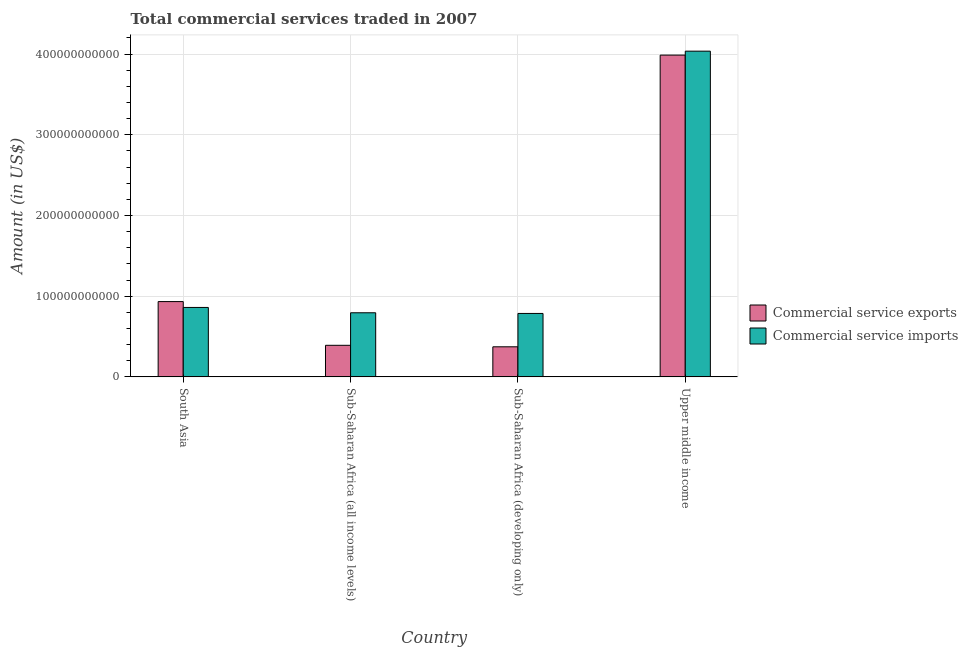How many different coloured bars are there?
Your answer should be very brief. 2. How many groups of bars are there?
Your answer should be very brief. 4. Are the number of bars per tick equal to the number of legend labels?
Keep it short and to the point. Yes. Are the number of bars on each tick of the X-axis equal?
Keep it short and to the point. Yes. What is the label of the 2nd group of bars from the left?
Make the answer very short. Sub-Saharan Africa (all income levels). What is the amount of commercial service imports in Upper middle income?
Provide a succinct answer. 4.04e+11. Across all countries, what is the maximum amount of commercial service imports?
Provide a short and direct response. 4.04e+11. Across all countries, what is the minimum amount of commercial service exports?
Provide a succinct answer. 3.73e+1. In which country was the amount of commercial service imports maximum?
Keep it short and to the point. Upper middle income. In which country was the amount of commercial service imports minimum?
Make the answer very short. Sub-Saharan Africa (developing only). What is the total amount of commercial service imports in the graph?
Ensure brevity in your answer.  6.48e+11. What is the difference between the amount of commercial service imports in Sub-Saharan Africa (all income levels) and that in Sub-Saharan Africa (developing only)?
Your answer should be very brief. 8.37e+08. What is the difference between the amount of commercial service imports in Sub-Saharan Africa (all income levels) and the amount of commercial service exports in Upper middle income?
Provide a succinct answer. -3.19e+11. What is the average amount of commercial service imports per country?
Keep it short and to the point. 1.62e+11. What is the difference between the amount of commercial service imports and amount of commercial service exports in Sub-Saharan Africa (all income levels)?
Your answer should be very brief. 4.03e+1. What is the ratio of the amount of commercial service imports in Sub-Saharan Africa (all income levels) to that in Upper middle income?
Offer a very short reply. 0.2. Is the amount of commercial service exports in Sub-Saharan Africa (developing only) less than that in Upper middle income?
Provide a short and direct response. Yes. What is the difference between the highest and the second highest amount of commercial service imports?
Offer a terse response. 3.18e+11. What is the difference between the highest and the lowest amount of commercial service imports?
Provide a succinct answer. 3.25e+11. What does the 1st bar from the left in South Asia represents?
Ensure brevity in your answer.  Commercial service exports. What does the 2nd bar from the right in Sub-Saharan Africa (all income levels) represents?
Your answer should be very brief. Commercial service exports. How many bars are there?
Keep it short and to the point. 8. Are all the bars in the graph horizontal?
Ensure brevity in your answer.  No. What is the difference between two consecutive major ticks on the Y-axis?
Offer a very short reply. 1.00e+11. Does the graph contain any zero values?
Ensure brevity in your answer.  No. Where does the legend appear in the graph?
Your answer should be compact. Center right. How many legend labels are there?
Give a very brief answer. 2. What is the title of the graph?
Keep it short and to the point. Total commercial services traded in 2007. What is the Amount (in US$) in Commercial service exports in South Asia?
Provide a short and direct response. 9.33e+1. What is the Amount (in US$) in Commercial service imports in South Asia?
Your answer should be very brief. 8.60e+1. What is the Amount (in US$) in Commercial service exports in Sub-Saharan Africa (all income levels)?
Keep it short and to the point. 3.91e+1. What is the Amount (in US$) of Commercial service imports in Sub-Saharan Africa (all income levels)?
Provide a short and direct response. 7.94e+1. What is the Amount (in US$) of Commercial service exports in Sub-Saharan Africa (developing only)?
Ensure brevity in your answer.  3.73e+1. What is the Amount (in US$) of Commercial service imports in Sub-Saharan Africa (developing only)?
Provide a succinct answer. 7.86e+1. What is the Amount (in US$) of Commercial service exports in Upper middle income?
Offer a very short reply. 3.99e+11. What is the Amount (in US$) of Commercial service imports in Upper middle income?
Make the answer very short. 4.04e+11. Across all countries, what is the maximum Amount (in US$) in Commercial service exports?
Offer a very short reply. 3.99e+11. Across all countries, what is the maximum Amount (in US$) in Commercial service imports?
Your answer should be very brief. 4.04e+11. Across all countries, what is the minimum Amount (in US$) of Commercial service exports?
Give a very brief answer. 3.73e+1. Across all countries, what is the minimum Amount (in US$) of Commercial service imports?
Provide a succinct answer. 7.86e+1. What is the total Amount (in US$) in Commercial service exports in the graph?
Give a very brief answer. 5.68e+11. What is the total Amount (in US$) of Commercial service imports in the graph?
Keep it short and to the point. 6.48e+11. What is the difference between the Amount (in US$) of Commercial service exports in South Asia and that in Sub-Saharan Africa (all income levels)?
Make the answer very short. 5.42e+1. What is the difference between the Amount (in US$) of Commercial service imports in South Asia and that in Sub-Saharan Africa (all income levels)?
Offer a very short reply. 6.59e+09. What is the difference between the Amount (in US$) of Commercial service exports in South Asia and that in Sub-Saharan Africa (developing only)?
Provide a succinct answer. 5.60e+1. What is the difference between the Amount (in US$) of Commercial service imports in South Asia and that in Sub-Saharan Africa (developing only)?
Your answer should be very brief. 7.43e+09. What is the difference between the Amount (in US$) in Commercial service exports in South Asia and that in Upper middle income?
Offer a very short reply. -3.05e+11. What is the difference between the Amount (in US$) of Commercial service imports in South Asia and that in Upper middle income?
Offer a very short reply. -3.18e+11. What is the difference between the Amount (in US$) of Commercial service exports in Sub-Saharan Africa (all income levels) and that in Sub-Saharan Africa (developing only)?
Your answer should be very brief. 1.86e+09. What is the difference between the Amount (in US$) of Commercial service imports in Sub-Saharan Africa (all income levels) and that in Sub-Saharan Africa (developing only)?
Offer a very short reply. 8.37e+08. What is the difference between the Amount (in US$) of Commercial service exports in Sub-Saharan Africa (all income levels) and that in Upper middle income?
Offer a terse response. -3.60e+11. What is the difference between the Amount (in US$) in Commercial service imports in Sub-Saharan Africa (all income levels) and that in Upper middle income?
Your response must be concise. -3.24e+11. What is the difference between the Amount (in US$) in Commercial service exports in Sub-Saharan Africa (developing only) and that in Upper middle income?
Your response must be concise. -3.61e+11. What is the difference between the Amount (in US$) of Commercial service imports in Sub-Saharan Africa (developing only) and that in Upper middle income?
Provide a succinct answer. -3.25e+11. What is the difference between the Amount (in US$) in Commercial service exports in South Asia and the Amount (in US$) in Commercial service imports in Sub-Saharan Africa (all income levels)?
Your answer should be compact. 1.39e+1. What is the difference between the Amount (in US$) in Commercial service exports in South Asia and the Amount (in US$) in Commercial service imports in Sub-Saharan Africa (developing only)?
Provide a short and direct response. 1.47e+1. What is the difference between the Amount (in US$) in Commercial service exports in South Asia and the Amount (in US$) in Commercial service imports in Upper middle income?
Give a very brief answer. -3.10e+11. What is the difference between the Amount (in US$) in Commercial service exports in Sub-Saharan Africa (all income levels) and the Amount (in US$) in Commercial service imports in Sub-Saharan Africa (developing only)?
Provide a succinct answer. -3.95e+1. What is the difference between the Amount (in US$) of Commercial service exports in Sub-Saharan Africa (all income levels) and the Amount (in US$) of Commercial service imports in Upper middle income?
Give a very brief answer. -3.64e+11. What is the difference between the Amount (in US$) in Commercial service exports in Sub-Saharan Africa (developing only) and the Amount (in US$) in Commercial service imports in Upper middle income?
Offer a terse response. -3.66e+11. What is the average Amount (in US$) in Commercial service exports per country?
Provide a short and direct response. 1.42e+11. What is the average Amount (in US$) in Commercial service imports per country?
Offer a very short reply. 1.62e+11. What is the difference between the Amount (in US$) of Commercial service exports and Amount (in US$) of Commercial service imports in South Asia?
Your answer should be compact. 7.27e+09. What is the difference between the Amount (in US$) in Commercial service exports and Amount (in US$) in Commercial service imports in Sub-Saharan Africa (all income levels)?
Provide a short and direct response. -4.03e+1. What is the difference between the Amount (in US$) in Commercial service exports and Amount (in US$) in Commercial service imports in Sub-Saharan Africa (developing only)?
Offer a terse response. -4.13e+1. What is the difference between the Amount (in US$) of Commercial service exports and Amount (in US$) of Commercial service imports in Upper middle income?
Your answer should be very brief. -4.89e+09. What is the ratio of the Amount (in US$) of Commercial service exports in South Asia to that in Sub-Saharan Africa (all income levels)?
Offer a very short reply. 2.38. What is the ratio of the Amount (in US$) in Commercial service imports in South Asia to that in Sub-Saharan Africa (all income levels)?
Offer a terse response. 1.08. What is the ratio of the Amount (in US$) in Commercial service exports in South Asia to that in Sub-Saharan Africa (developing only)?
Offer a very short reply. 2.5. What is the ratio of the Amount (in US$) of Commercial service imports in South Asia to that in Sub-Saharan Africa (developing only)?
Ensure brevity in your answer.  1.09. What is the ratio of the Amount (in US$) in Commercial service exports in South Asia to that in Upper middle income?
Offer a terse response. 0.23. What is the ratio of the Amount (in US$) in Commercial service imports in South Asia to that in Upper middle income?
Ensure brevity in your answer.  0.21. What is the ratio of the Amount (in US$) in Commercial service exports in Sub-Saharan Africa (all income levels) to that in Sub-Saharan Africa (developing only)?
Provide a short and direct response. 1.05. What is the ratio of the Amount (in US$) in Commercial service imports in Sub-Saharan Africa (all income levels) to that in Sub-Saharan Africa (developing only)?
Offer a very short reply. 1.01. What is the ratio of the Amount (in US$) in Commercial service exports in Sub-Saharan Africa (all income levels) to that in Upper middle income?
Offer a terse response. 0.1. What is the ratio of the Amount (in US$) of Commercial service imports in Sub-Saharan Africa (all income levels) to that in Upper middle income?
Provide a short and direct response. 0.2. What is the ratio of the Amount (in US$) of Commercial service exports in Sub-Saharan Africa (developing only) to that in Upper middle income?
Ensure brevity in your answer.  0.09. What is the ratio of the Amount (in US$) of Commercial service imports in Sub-Saharan Africa (developing only) to that in Upper middle income?
Your response must be concise. 0.19. What is the difference between the highest and the second highest Amount (in US$) of Commercial service exports?
Provide a short and direct response. 3.05e+11. What is the difference between the highest and the second highest Amount (in US$) in Commercial service imports?
Keep it short and to the point. 3.18e+11. What is the difference between the highest and the lowest Amount (in US$) of Commercial service exports?
Your answer should be compact. 3.61e+11. What is the difference between the highest and the lowest Amount (in US$) of Commercial service imports?
Offer a very short reply. 3.25e+11. 